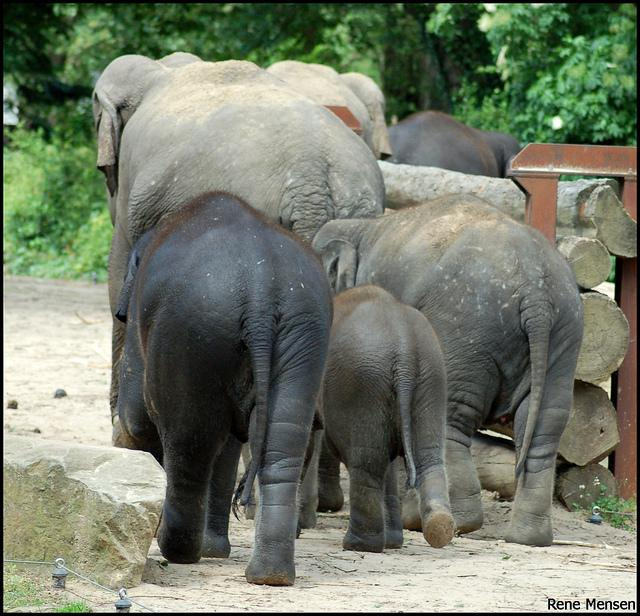What is this group of animals called?

Choices:
A) clowder
B) school
C) herd
D) pride herd 